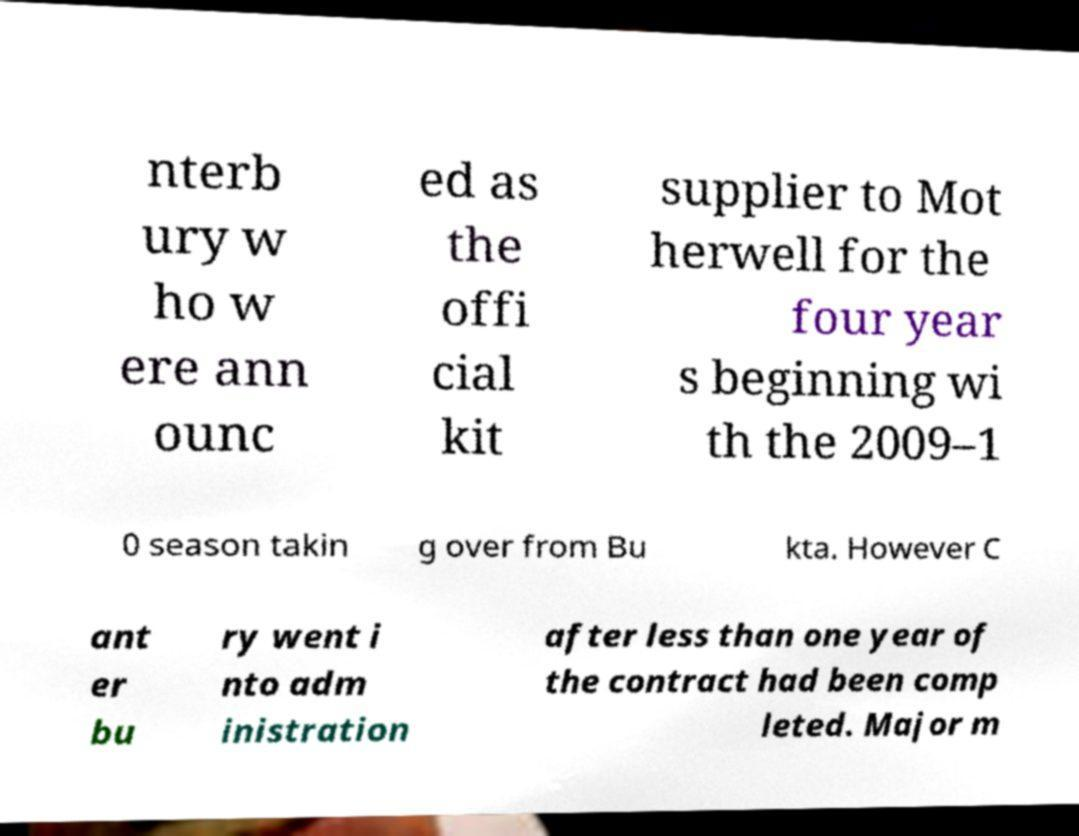For documentation purposes, I need the text within this image transcribed. Could you provide that? nterb ury w ho w ere ann ounc ed as the offi cial kit supplier to Mot herwell for the four year s beginning wi th the 2009–1 0 season takin g over from Bu kta. However C ant er bu ry went i nto adm inistration after less than one year of the contract had been comp leted. Major m 